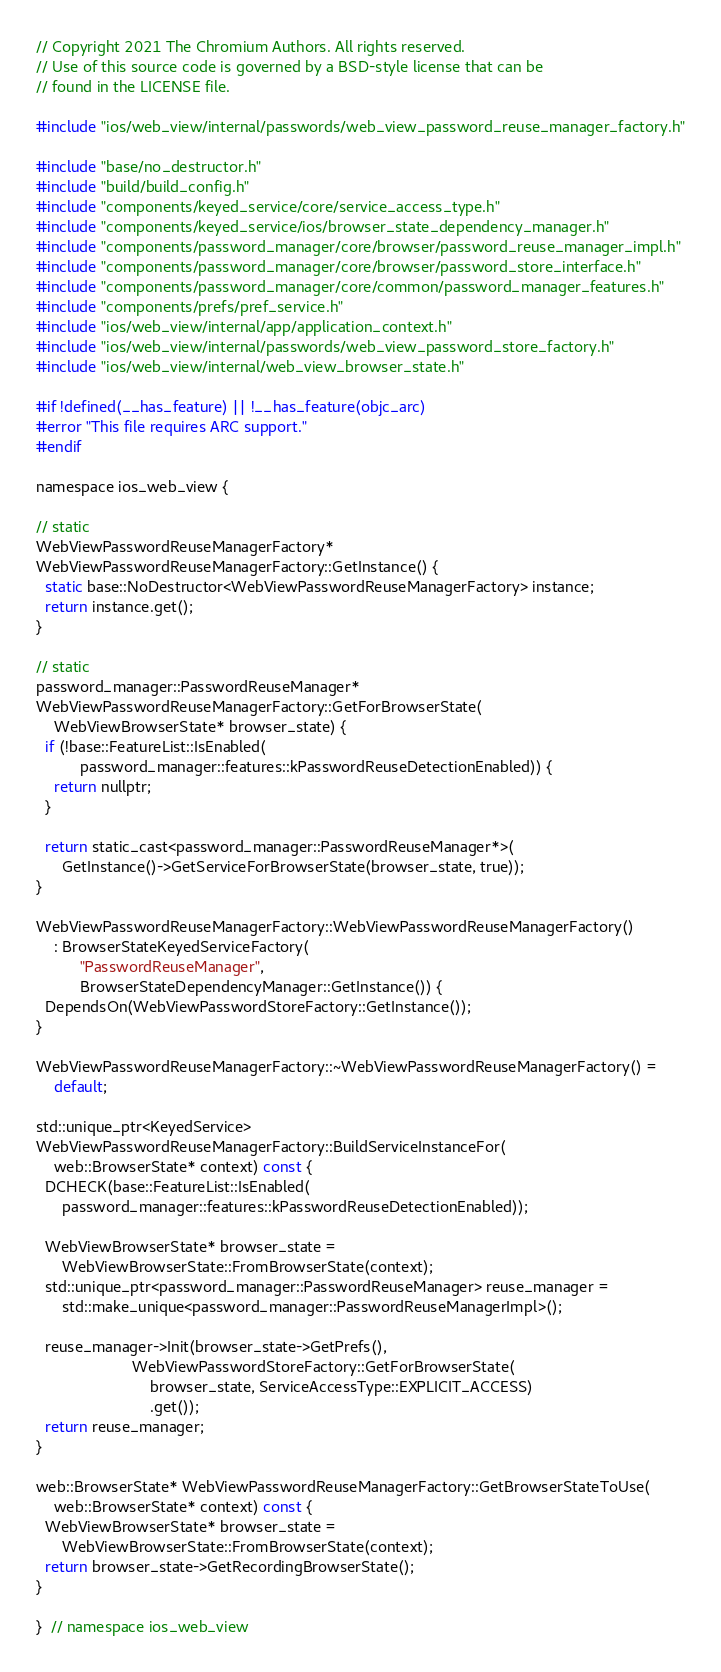Convert code to text. <code><loc_0><loc_0><loc_500><loc_500><_ObjectiveC_>// Copyright 2021 The Chromium Authors. All rights reserved.
// Use of this source code is governed by a BSD-style license that can be
// found in the LICENSE file.

#include "ios/web_view/internal/passwords/web_view_password_reuse_manager_factory.h"

#include "base/no_destructor.h"
#include "build/build_config.h"
#include "components/keyed_service/core/service_access_type.h"
#include "components/keyed_service/ios/browser_state_dependency_manager.h"
#include "components/password_manager/core/browser/password_reuse_manager_impl.h"
#include "components/password_manager/core/browser/password_store_interface.h"
#include "components/password_manager/core/common/password_manager_features.h"
#include "components/prefs/pref_service.h"
#include "ios/web_view/internal/app/application_context.h"
#include "ios/web_view/internal/passwords/web_view_password_store_factory.h"
#include "ios/web_view/internal/web_view_browser_state.h"

#if !defined(__has_feature) || !__has_feature(objc_arc)
#error "This file requires ARC support."
#endif

namespace ios_web_view {

// static
WebViewPasswordReuseManagerFactory*
WebViewPasswordReuseManagerFactory::GetInstance() {
  static base::NoDestructor<WebViewPasswordReuseManagerFactory> instance;
  return instance.get();
}

// static
password_manager::PasswordReuseManager*
WebViewPasswordReuseManagerFactory::GetForBrowserState(
    WebViewBrowserState* browser_state) {
  if (!base::FeatureList::IsEnabled(
          password_manager::features::kPasswordReuseDetectionEnabled)) {
    return nullptr;
  }

  return static_cast<password_manager::PasswordReuseManager*>(
      GetInstance()->GetServiceForBrowserState(browser_state, true));
}

WebViewPasswordReuseManagerFactory::WebViewPasswordReuseManagerFactory()
    : BrowserStateKeyedServiceFactory(
          "PasswordReuseManager",
          BrowserStateDependencyManager::GetInstance()) {
  DependsOn(WebViewPasswordStoreFactory::GetInstance());
}

WebViewPasswordReuseManagerFactory::~WebViewPasswordReuseManagerFactory() =
    default;

std::unique_ptr<KeyedService>
WebViewPasswordReuseManagerFactory::BuildServiceInstanceFor(
    web::BrowserState* context) const {
  DCHECK(base::FeatureList::IsEnabled(
      password_manager::features::kPasswordReuseDetectionEnabled));

  WebViewBrowserState* browser_state =
      WebViewBrowserState::FromBrowserState(context);
  std::unique_ptr<password_manager::PasswordReuseManager> reuse_manager =
      std::make_unique<password_manager::PasswordReuseManagerImpl>();

  reuse_manager->Init(browser_state->GetPrefs(),
                      WebViewPasswordStoreFactory::GetForBrowserState(
                          browser_state, ServiceAccessType::EXPLICIT_ACCESS)
                          .get());
  return reuse_manager;
}

web::BrowserState* WebViewPasswordReuseManagerFactory::GetBrowserStateToUse(
    web::BrowserState* context) const {
  WebViewBrowserState* browser_state =
      WebViewBrowserState::FromBrowserState(context);
  return browser_state->GetRecordingBrowserState();
}

}  // namespace ios_web_view
</code> 